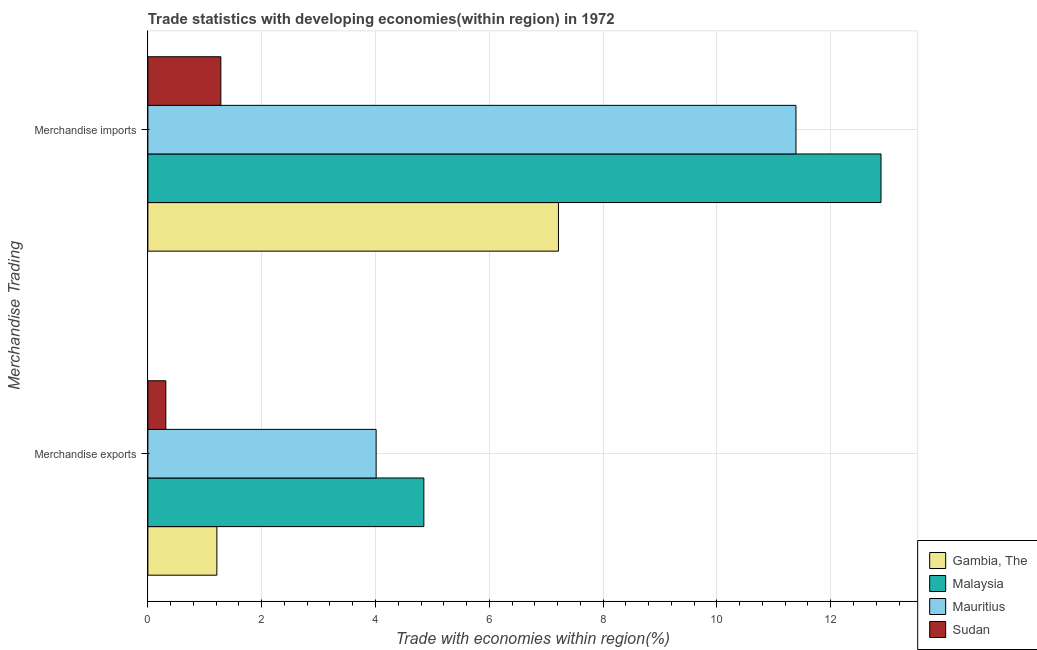How many different coloured bars are there?
Give a very brief answer. 4. How many groups of bars are there?
Your response must be concise. 2. Are the number of bars per tick equal to the number of legend labels?
Your response must be concise. Yes. How many bars are there on the 1st tick from the top?
Your response must be concise. 4. How many bars are there on the 2nd tick from the bottom?
Provide a succinct answer. 4. What is the merchandise imports in Mauritius?
Provide a succinct answer. 11.39. Across all countries, what is the maximum merchandise imports?
Your answer should be very brief. 12.88. Across all countries, what is the minimum merchandise imports?
Provide a succinct answer. 1.28. In which country was the merchandise imports maximum?
Make the answer very short. Malaysia. In which country was the merchandise exports minimum?
Make the answer very short. Sudan. What is the total merchandise imports in the graph?
Provide a succinct answer. 32.77. What is the difference between the merchandise imports in Mauritius and that in Gambia, The?
Provide a succinct answer. 4.17. What is the difference between the merchandise imports in Sudan and the merchandise exports in Gambia, The?
Offer a very short reply. 0.07. What is the average merchandise imports per country?
Your answer should be very brief. 8.19. What is the difference between the merchandise exports and merchandise imports in Mauritius?
Make the answer very short. -7.38. What is the ratio of the merchandise imports in Malaysia to that in Sudan?
Offer a terse response. 10.05. What does the 2nd bar from the top in Merchandise exports represents?
Ensure brevity in your answer.  Mauritius. What does the 4th bar from the bottom in Merchandise imports represents?
Provide a short and direct response. Sudan. How many countries are there in the graph?
Provide a short and direct response. 4. Are the values on the major ticks of X-axis written in scientific E-notation?
Keep it short and to the point. No. Does the graph contain grids?
Keep it short and to the point. Yes. How are the legend labels stacked?
Give a very brief answer. Vertical. What is the title of the graph?
Your answer should be compact. Trade statistics with developing economies(within region) in 1972. Does "South Africa" appear as one of the legend labels in the graph?
Your answer should be compact. No. What is the label or title of the X-axis?
Provide a succinct answer. Trade with economies within region(%). What is the label or title of the Y-axis?
Make the answer very short. Merchandise Trading. What is the Trade with economies within region(%) of Gambia, The in Merchandise exports?
Ensure brevity in your answer.  1.21. What is the Trade with economies within region(%) in Malaysia in Merchandise exports?
Make the answer very short. 4.85. What is the Trade with economies within region(%) of Mauritius in Merchandise exports?
Offer a very short reply. 4.01. What is the Trade with economies within region(%) of Sudan in Merchandise exports?
Provide a succinct answer. 0.32. What is the Trade with economies within region(%) in Gambia, The in Merchandise imports?
Provide a short and direct response. 7.22. What is the Trade with economies within region(%) in Malaysia in Merchandise imports?
Keep it short and to the point. 12.88. What is the Trade with economies within region(%) in Mauritius in Merchandise imports?
Make the answer very short. 11.39. What is the Trade with economies within region(%) of Sudan in Merchandise imports?
Your answer should be compact. 1.28. Across all Merchandise Trading, what is the maximum Trade with economies within region(%) of Gambia, The?
Keep it short and to the point. 7.22. Across all Merchandise Trading, what is the maximum Trade with economies within region(%) of Malaysia?
Your answer should be very brief. 12.88. Across all Merchandise Trading, what is the maximum Trade with economies within region(%) in Mauritius?
Your answer should be very brief. 11.39. Across all Merchandise Trading, what is the maximum Trade with economies within region(%) of Sudan?
Your answer should be very brief. 1.28. Across all Merchandise Trading, what is the minimum Trade with economies within region(%) in Gambia, The?
Ensure brevity in your answer.  1.21. Across all Merchandise Trading, what is the minimum Trade with economies within region(%) in Malaysia?
Offer a very short reply. 4.85. Across all Merchandise Trading, what is the minimum Trade with economies within region(%) in Mauritius?
Ensure brevity in your answer.  4.01. Across all Merchandise Trading, what is the minimum Trade with economies within region(%) in Sudan?
Ensure brevity in your answer.  0.32. What is the total Trade with economies within region(%) in Gambia, The in the graph?
Provide a succinct answer. 8.43. What is the total Trade with economies within region(%) in Malaysia in the graph?
Your answer should be compact. 17.73. What is the total Trade with economies within region(%) in Mauritius in the graph?
Offer a terse response. 15.4. What is the total Trade with economies within region(%) in Sudan in the graph?
Ensure brevity in your answer.  1.6. What is the difference between the Trade with economies within region(%) in Gambia, The in Merchandise exports and that in Merchandise imports?
Your answer should be very brief. -6. What is the difference between the Trade with economies within region(%) of Malaysia in Merchandise exports and that in Merchandise imports?
Provide a short and direct response. -8.03. What is the difference between the Trade with economies within region(%) of Mauritius in Merchandise exports and that in Merchandise imports?
Ensure brevity in your answer.  -7.38. What is the difference between the Trade with economies within region(%) in Sudan in Merchandise exports and that in Merchandise imports?
Provide a succinct answer. -0.97. What is the difference between the Trade with economies within region(%) in Gambia, The in Merchandise exports and the Trade with economies within region(%) in Malaysia in Merchandise imports?
Your answer should be compact. -11.67. What is the difference between the Trade with economies within region(%) in Gambia, The in Merchandise exports and the Trade with economies within region(%) in Mauritius in Merchandise imports?
Make the answer very short. -10.18. What is the difference between the Trade with economies within region(%) in Gambia, The in Merchandise exports and the Trade with economies within region(%) in Sudan in Merchandise imports?
Ensure brevity in your answer.  -0.07. What is the difference between the Trade with economies within region(%) in Malaysia in Merchandise exports and the Trade with economies within region(%) in Mauritius in Merchandise imports?
Keep it short and to the point. -6.54. What is the difference between the Trade with economies within region(%) in Malaysia in Merchandise exports and the Trade with economies within region(%) in Sudan in Merchandise imports?
Ensure brevity in your answer.  3.57. What is the difference between the Trade with economies within region(%) of Mauritius in Merchandise exports and the Trade with economies within region(%) of Sudan in Merchandise imports?
Make the answer very short. 2.73. What is the average Trade with economies within region(%) of Gambia, The per Merchandise Trading?
Your response must be concise. 4.21. What is the average Trade with economies within region(%) in Malaysia per Merchandise Trading?
Keep it short and to the point. 8.87. What is the average Trade with economies within region(%) of Mauritius per Merchandise Trading?
Keep it short and to the point. 7.7. What is the average Trade with economies within region(%) in Sudan per Merchandise Trading?
Offer a very short reply. 0.8. What is the difference between the Trade with economies within region(%) of Gambia, The and Trade with economies within region(%) of Malaysia in Merchandise exports?
Your answer should be very brief. -3.64. What is the difference between the Trade with economies within region(%) in Gambia, The and Trade with economies within region(%) in Mauritius in Merchandise exports?
Ensure brevity in your answer.  -2.8. What is the difference between the Trade with economies within region(%) in Gambia, The and Trade with economies within region(%) in Sudan in Merchandise exports?
Your answer should be compact. 0.9. What is the difference between the Trade with economies within region(%) of Malaysia and Trade with economies within region(%) of Mauritius in Merchandise exports?
Offer a very short reply. 0.84. What is the difference between the Trade with economies within region(%) in Malaysia and Trade with economies within region(%) in Sudan in Merchandise exports?
Give a very brief answer. 4.53. What is the difference between the Trade with economies within region(%) in Mauritius and Trade with economies within region(%) in Sudan in Merchandise exports?
Offer a very short reply. 3.7. What is the difference between the Trade with economies within region(%) in Gambia, The and Trade with economies within region(%) in Malaysia in Merchandise imports?
Make the answer very short. -5.67. What is the difference between the Trade with economies within region(%) of Gambia, The and Trade with economies within region(%) of Mauritius in Merchandise imports?
Your answer should be compact. -4.17. What is the difference between the Trade with economies within region(%) in Gambia, The and Trade with economies within region(%) in Sudan in Merchandise imports?
Keep it short and to the point. 5.93. What is the difference between the Trade with economies within region(%) of Malaysia and Trade with economies within region(%) of Mauritius in Merchandise imports?
Offer a very short reply. 1.49. What is the difference between the Trade with economies within region(%) of Malaysia and Trade with economies within region(%) of Sudan in Merchandise imports?
Make the answer very short. 11.6. What is the difference between the Trade with economies within region(%) of Mauritius and Trade with economies within region(%) of Sudan in Merchandise imports?
Your answer should be very brief. 10.11. What is the ratio of the Trade with economies within region(%) in Gambia, The in Merchandise exports to that in Merchandise imports?
Your answer should be compact. 0.17. What is the ratio of the Trade with economies within region(%) of Malaysia in Merchandise exports to that in Merchandise imports?
Give a very brief answer. 0.38. What is the ratio of the Trade with economies within region(%) of Mauritius in Merchandise exports to that in Merchandise imports?
Your answer should be very brief. 0.35. What is the ratio of the Trade with economies within region(%) in Sudan in Merchandise exports to that in Merchandise imports?
Provide a succinct answer. 0.25. What is the difference between the highest and the second highest Trade with economies within region(%) of Gambia, The?
Ensure brevity in your answer.  6. What is the difference between the highest and the second highest Trade with economies within region(%) in Malaysia?
Make the answer very short. 8.03. What is the difference between the highest and the second highest Trade with economies within region(%) in Mauritius?
Give a very brief answer. 7.38. What is the difference between the highest and the second highest Trade with economies within region(%) of Sudan?
Make the answer very short. 0.97. What is the difference between the highest and the lowest Trade with economies within region(%) in Gambia, The?
Make the answer very short. 6. What is the difference between the highest and the lowest Trade with economies within region(%) in Malaysia?
Offer a terse response. 8.03. What is the difference between the highest and the lowest Trade with economies within region(%) of Mauritius?
Provide a succinct answer. 7.38. What is the difference between the highest and the lowest Trade with economies within region(%) of Sudan?
Keep it short and to the point. 0.97. 